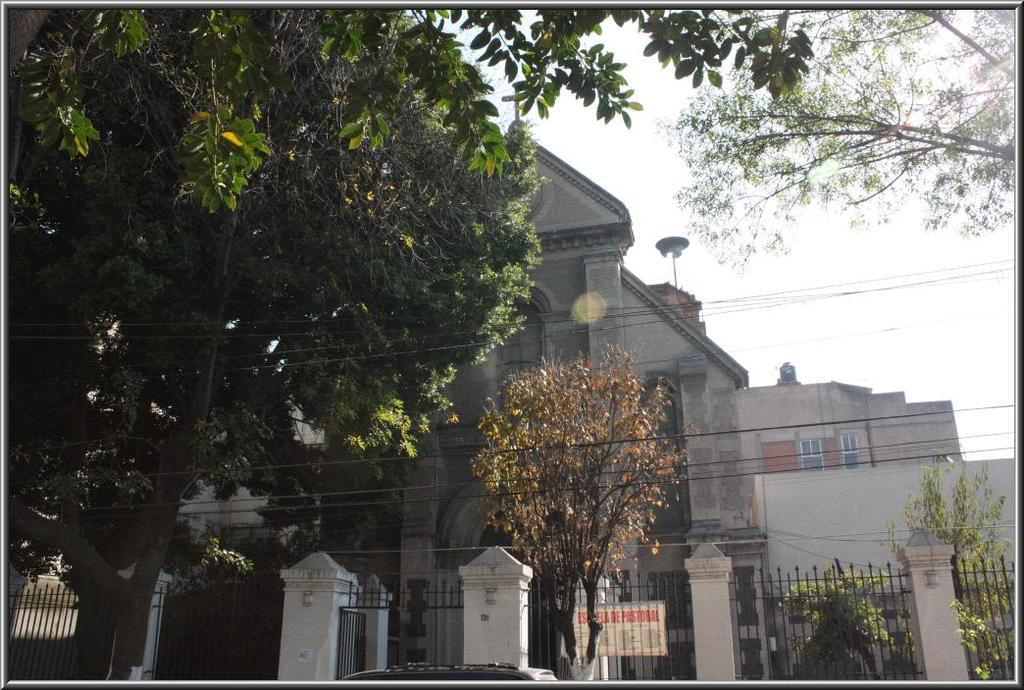What type of structures can be seen in the image? There are buildings in the image. What is present alongside the buildings? There is a fencing in the image. What is attached to the fencing? There is a board attached to the fencing. What type of vegetation is visible in the image? There are trees and plants in the image. How does the journey of the trail impact the plants in the image? There is no journey or trail present in the image; it features buildings, fencing, a board, trees, and plants. 